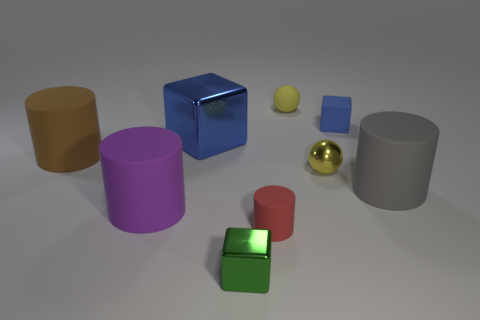Subtract all green cubes. How many cubes are left? 2 Add 1 green shiny cubes. How many objects exist? 10 Subtract all gray spheres. How many blue blocks are left? 2 Subtract all green cubes. How many cubes are left? 2 Subtract all cubes. How many objects are left? 6 Subtract 2 balls. How many balls are left? 0 Subtract 0 cyan blocks. How many objects are left? 9 Subtract all red cylinders. Subtract all red balls. How many cylinders are left? 3 Subtract all large cyan matte cylinders. Subtract all large things. How many objects are left? 5 Add 9 rubber spheres. How many rubber spheres are left? 10 